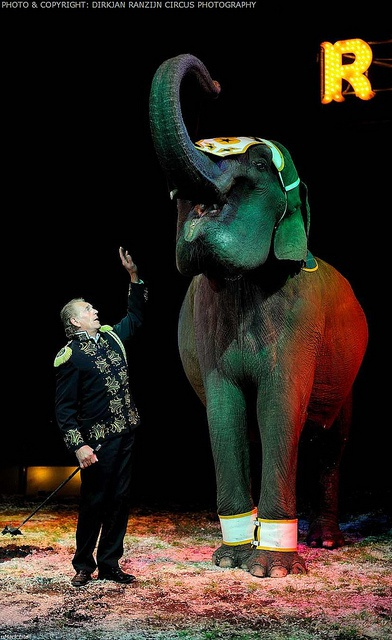Describe the objects in this image and their specific colors. I can see elephant in black, maroon, teal, and darkgreen tones and people in black, gray, darkgray, and tan tones in this image. 